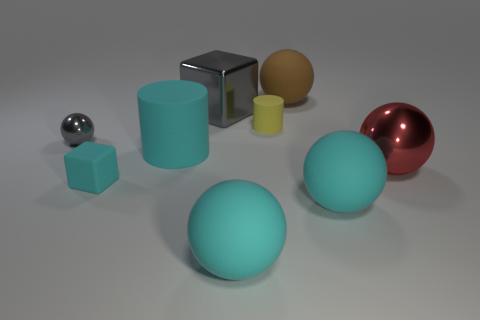Subtract all gray spheres. How many spheres are left? 4 Subtract all gray balls. How many balls are left? 4 Subtract all green spheres. Subtract all red cylinders. How many spheres are left? 5 Add 1 small cyan rubber things. How many objects exist? 10 Subtract all cubes. How many objects are left? 7 Subtract all rubber blocks. Subtract all gray metal spheres. How many objects are left? 7 Add 7 small matte things. How many small matte things are left? 9 Add 3 big blue metallic cylinders. How many big blue metallic cylinders exist? 3 Subtract 1 brown spheres. How many objects are left? 8 